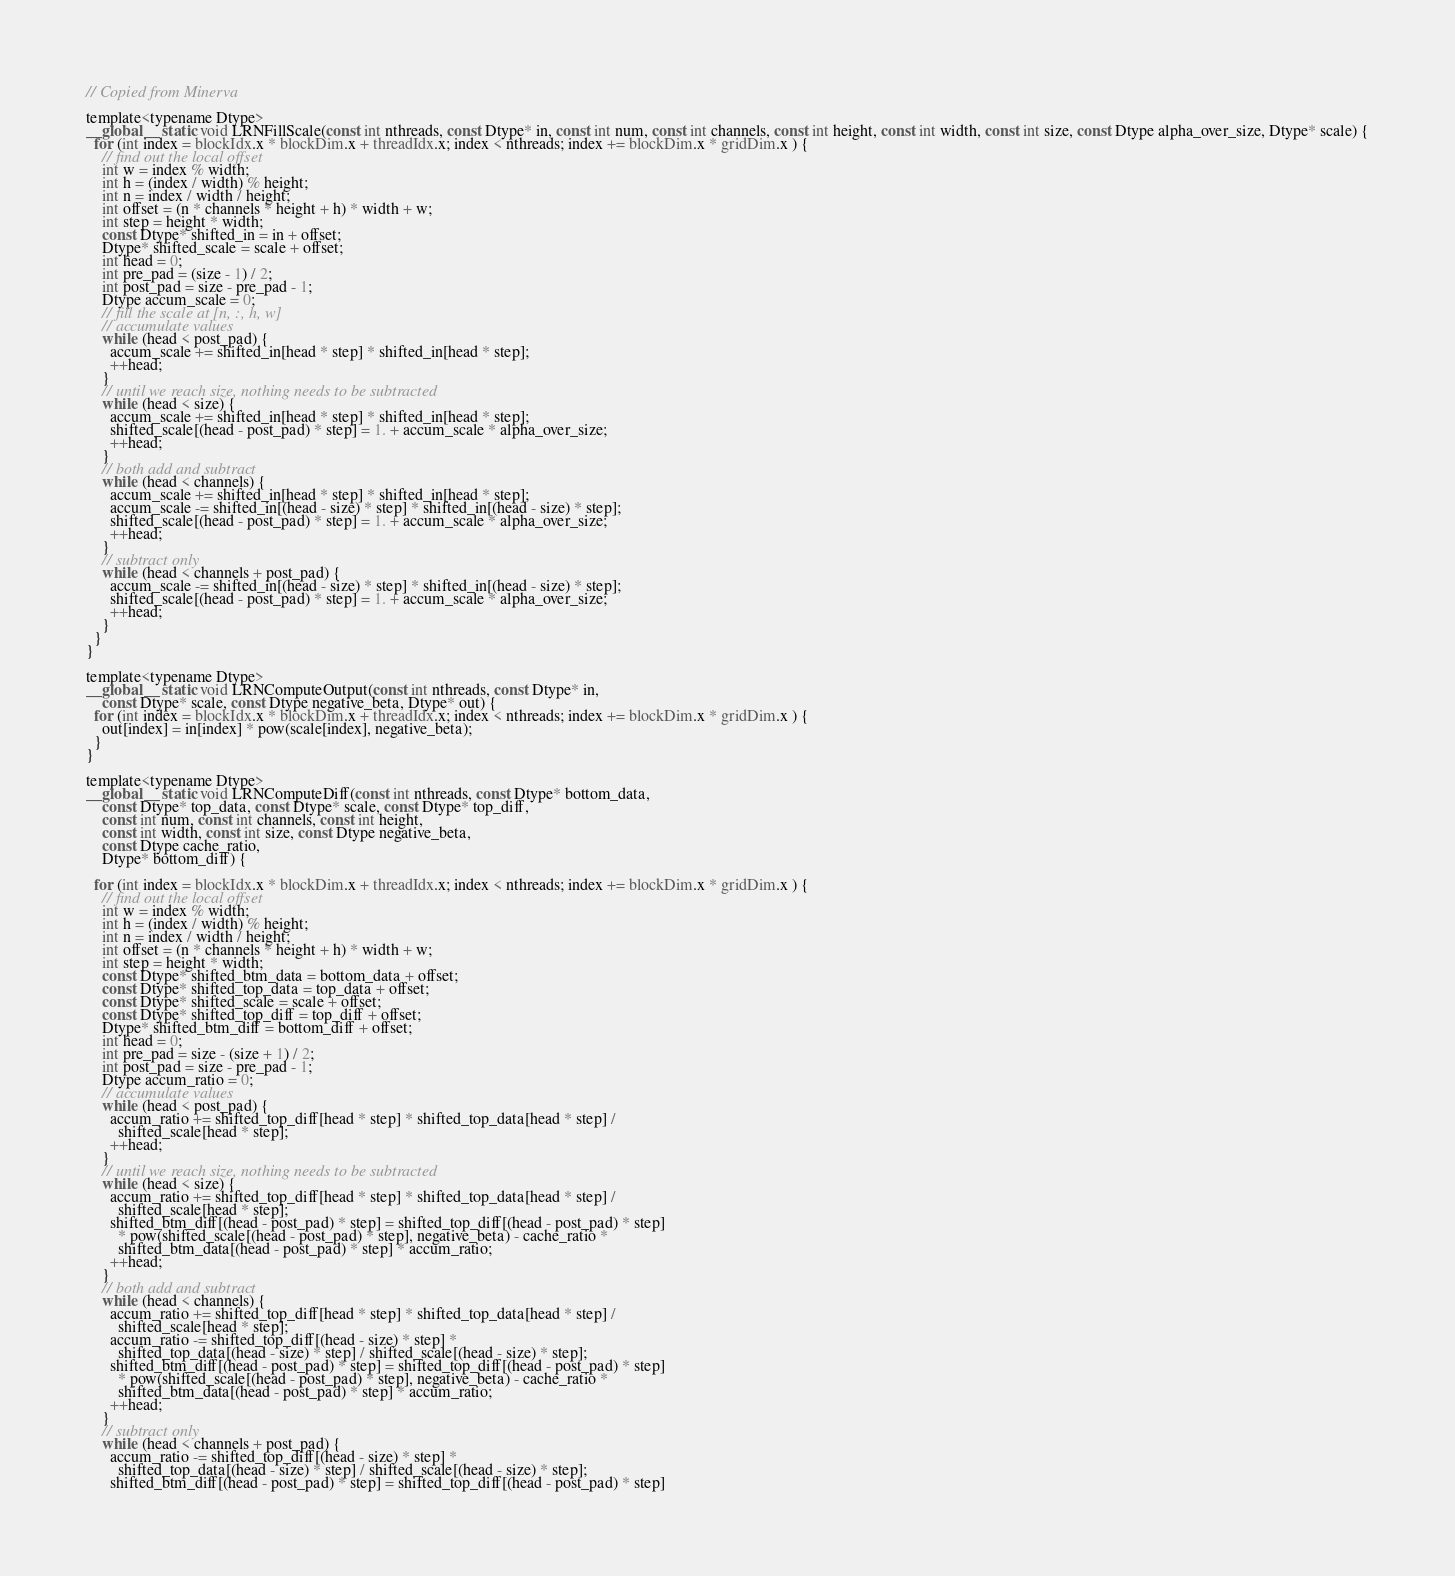<code> <loc_0><loc_0><loc_500><loc_500><_Cuda_>// Copied from Minerva

template<typename Dtype>
__global__ static void LRNFillScale(const int nthreads, const Dtype* in, const int num, const int channels, const int height, const int width, const int size, const Dtype alpha_over_size, Dtype* scale) {
  for (int index = blockIdx.x * blockDim.x + threadIdx.x; index < nthreads; index += blockDim.x * gridDim.x ) {
    // find out the local offset
    int w = index % width;
    int h = (index / width) % height;
    int n = index / width / height;
    int offset = (n * channels * height + h) * width + w;
    int step = height * width;
    const Dtype* shifted_in = in + offset;
    Dtype* shifted_scale = scale + offset;
    int head = 0;
    int pre_pad = (size - 1) / 2;
    int post_pad = size - pre_pad - 1;
    Dtype accum_scale = 0;
    // fill the scale at [n, :, h, w]
    // accumulate values
    while (head < post_pad) {
      accum_scale += shifted_in[head * step] * shifted_in[head * step];
      ++head;
    }
    // until we reach size, nothing needs to be subtracted
    while (head < size) {
      accum_scale += shifted_in[head * step] * shifted_in[head * step];
      shifted_scale[(head - post_pad) * step] = 1. + accum_scale * alpha_over_size;
      ++head;
    }
    // both add and subtract
    while (head < channels) {
      accum_scale += shifted_in[head * step] * shifted_in[head * step];
      accum_scale -= shifted_in[(head - size) * step] * shifted_in[(head - size) * step];
      shifted_scale[(head - post_pad) * step] = 1. + accum_scale * alpha_over_size;
      ++head;
    }
    // subtract only
    while (head < channels + post_pad) {
      accum_scale -= shifted_in[(head - size) * step] * shifted_in[(head - size) * step];
      shifted_scale[(head - post_pad) * step] = 1. + accum_scale * alpha_over_size;
      ++head;
    }
  }
}

template<typename Dtype>
__global__ static void LRNComputeOutput(const int nthreads, const Dtype* in,
    const Dtype* scale, const Dtype negative_beta, Dtype* out) {
  for (int index = blockIdx.x * blockDim.x + threadIdx.x; index < nthreads; index += blockDim.x * gridDim.x ) {
    out[index] = in[index] * pow(scale[index], negative_beta);
  }
}

template<typename Dtype>
__global__ static void LRNComputeDiff(const int nthreads, const Dtype* bottom_data,
    const Dtype* top_data, const Dtype* scale, const Dtype* top_diff,
    const int num, const int channels, const int height,
    const int width, const int size, const Dtype negative_beta,
    const Dtype cache_ratio,
    Dtype* bottom_diff) {

  for (int index = blockIdx.x * blockDim.x + threadIdx.x; index < nthreads; index += blockDim.x * gridDim.x ) {
    // find out the local offset
    int w = index % width;
    int h = (index / width) % height;
    int n = index / width / height;
    int offset = (n * channels * height + h) * width + w;
    int step = height * width;
    const Dtype* shifted_btm_data = bottom_data + offset;
    const Dtype* shifted_top_data = top_data + offset;
    const Dtype* shifted_scale = scale + offset;
    const Dtype* shifted_top_diff = top_diff + offset;
    Dtype* shifted_btm_diff = bottom_diff + offset;
    int head = 0;
    int pre_pad = size - (size + 1) / 2;
    int post_pad = size - pre_pad - 1;
    Dtype accum_ratio = 0;
    // accumulate values
    while (head < post_pad) {
      accum_ratio += shifted_top_diff[head * step] * shifted_top_data[head * step] /
        shifted_scale[head * step];
      ++head;
    }
    // until we reach size, nothing needs to be subtracted
    while (head < size) {
      accum_ratio += shifted_top_diff[head * step] * shifted_top_data[head * step] /
        shifted_scale[head * step];
      shifted_btm_diff[(head - post_pad) * step] = shifted_top_diff[(head - post_pad) * step]
        * pow(shifted_scale[(head - post_pad) * step], negative_beta) - cache_ratio *
        shifted_btm_data[(head - post_pad) * step] * accum_ratio;
      ++head;
    }
    // both add and subtract
    while (head < channels) {
      accum_ratio += shifted_top_diff[head * step] * shifted_top_data[head * step] /
        shifted_scale[head * step];
      accum_ratio -= shifted_top_diff[(head - size) * step] *
        shifted_top_data[(head - size) * step] / shifted_scale[(head - size) * step];
      shifted_btm_diff[(head - post_pad) * step] = shifted_top_diff[(head - post_pad) * step]
        * pow(shifted_scale[(head - post_pad) * step], negative_beta) - cache_ratio *
        shifted_btm_data[(head - post_pad) * step] * accum_ratio;
      ++head;
    }
    // subtract only
    while (head < channels + post_pad) {
      accum_ratio -= shifted_top_diff[(head - size) * step] *
        shifted_top_data[(head - size) * step] / shifted_scale[(head - size) * step];
      shifted_btm_diff[(head - post_pad) * step] = shifted_top_diff[(head - post_pad) * step]</code> 